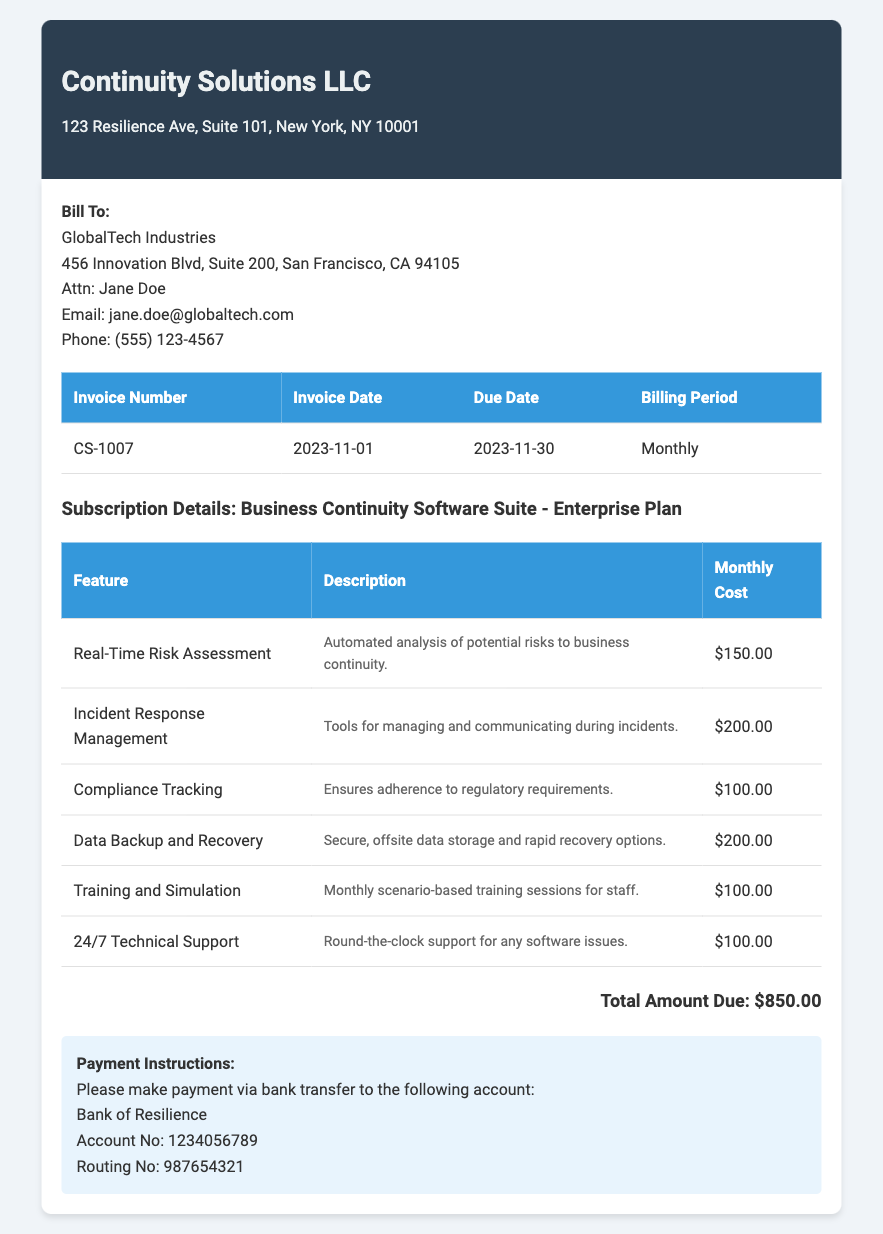What is the invoice number? The invoice number is specified in the document table as CS-1007.
Answer: CS-1007 What is the due date for the invoice? The due date of the invoice can be found in the document under the corresponding table as 2023-11-30.
Answer: 2023-11-30 How much does the Data Backup and Recovery feature cost? This cost is detailed in the feature table as $200.00.
Answer: $200.00 What is the total amount due? The total amount due is provided in the document as $850.00.
Answer: $850.00 Who is the client being billed? The client's name is listed at the top of the document, which is GlobalTech Industries.
Answer: GlobalTech Industries What feature provides 24/7 support? The feature that offers this service is listed as 24/7 Technical Support in the itemized section.
Answer: 24/7 Technical Support How many features are itemized in the invoice? The document includes a list of six specific features under Subscription Details.
Answer: Six What bank should the payment be transferred to? The document specifies making the payment to the Bank of Resilience.
Answer: Bank of Resilience What is the monthly cost of Incident Response Management? The cost is given in the table of features as $200.00.
Answer: $200.00 